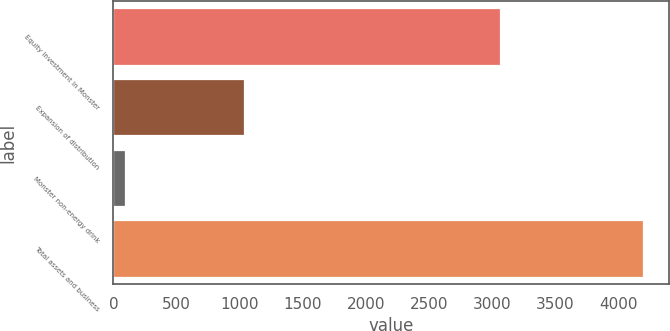<chart> <loc_0><loc_0><loc_500><loc_500><bar_chart><fcel>Equity investment in Monster<fcel>Expansion of distribution<fcel>Monster non-energy drink<fcel>Total assets and business<nl><fcel>3066<fcel>1035<fcel>95<fcel>4196<nl></chart> 